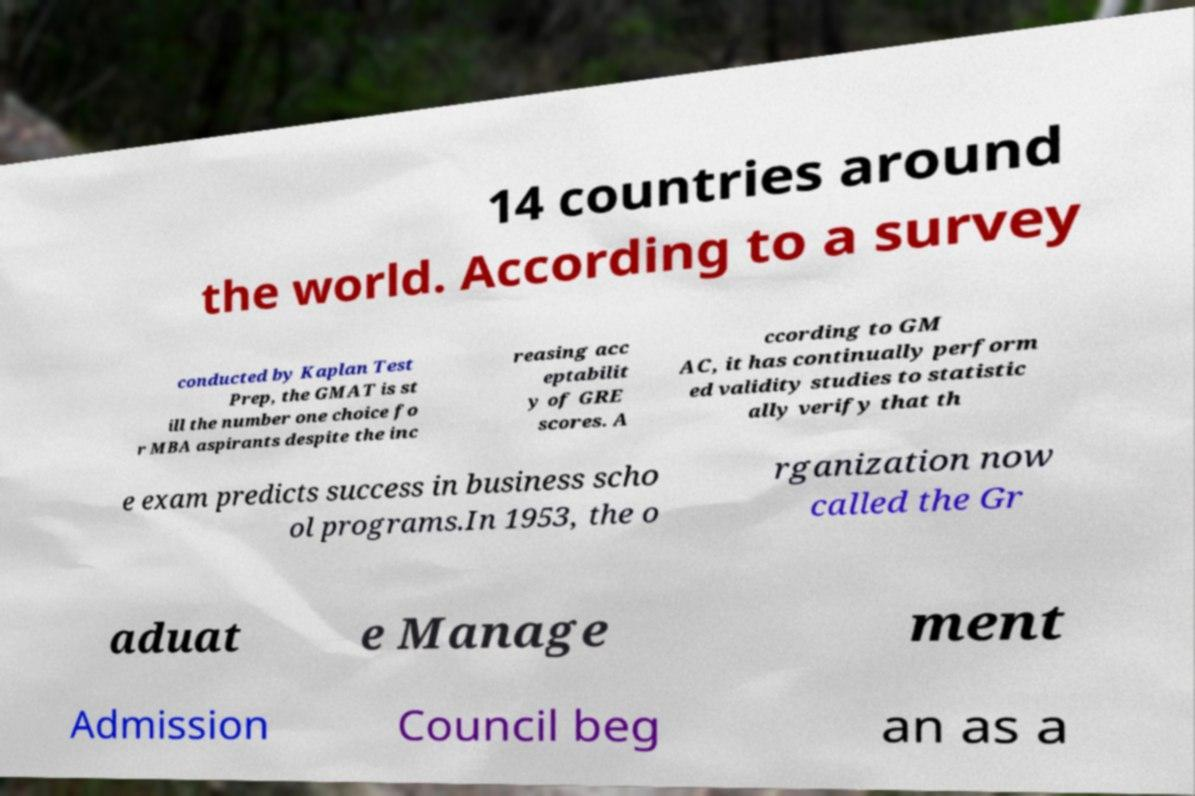Could you extract and type out the text from this image? 14 countries around the world. According to a survey conducted by Kaplan Test Prep, the GMAT is st ill the number one choice fo r MBA aspirants despite the inc reasing acc eptabilit y of GRE scores. A ccording to GM AC, it has continually perform ed validity studies to statistic ally verify that th e exam predicts success in business scho ol programs.In 1953, the o rganization now called the Gr aduat e Manage ment Admission Council beg an as a 